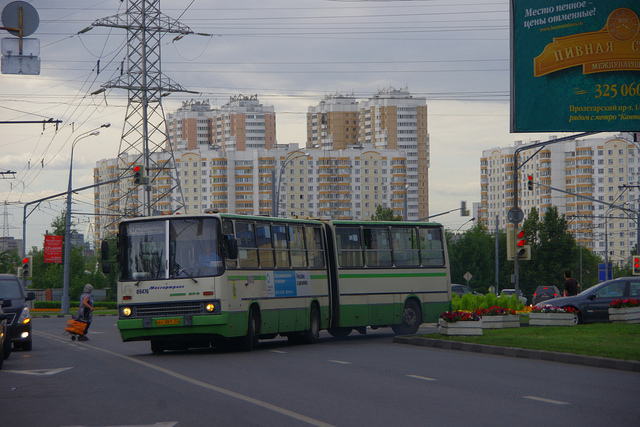<image>What does the green sign on the right say? I don't know what the green sign on the right says. It may say '325 06', 'dhabihah', or a Russian phrase. However, it is in a different language and is hard to read. What does the green sign on the right say? I am not sure what the green sign on the right says. It could be '325 06', '325', 'russian advertisement', 'dhabihah', 'different language can't read', or 'russian phrase'. 